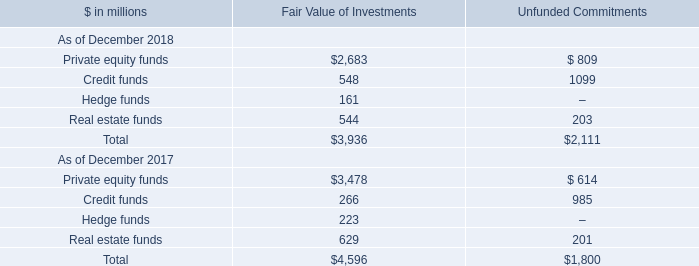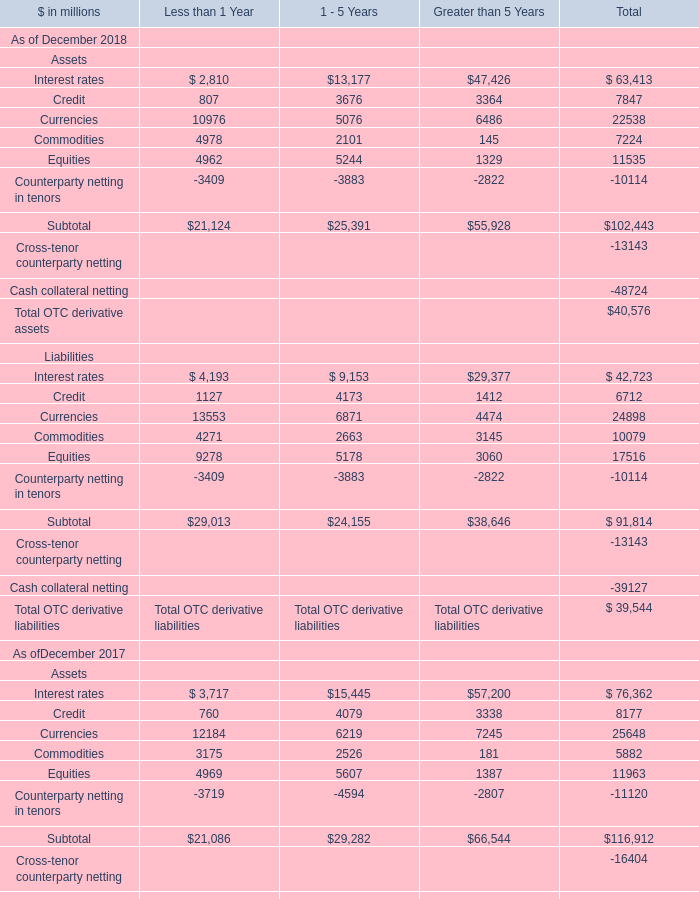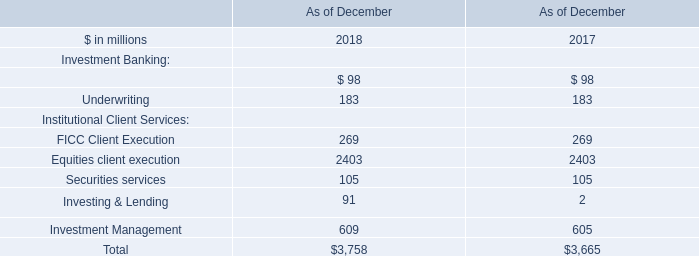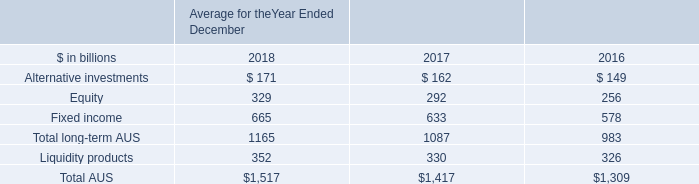What is the total amount of Interest rates Liabilities of Less than 1 Year is, Credit funds of Unfunded Commitments, and Subtotal of Total ? 
Computations: ((4517.0 + 1099.0) + 102443.0)
Answer: 108059.0. 